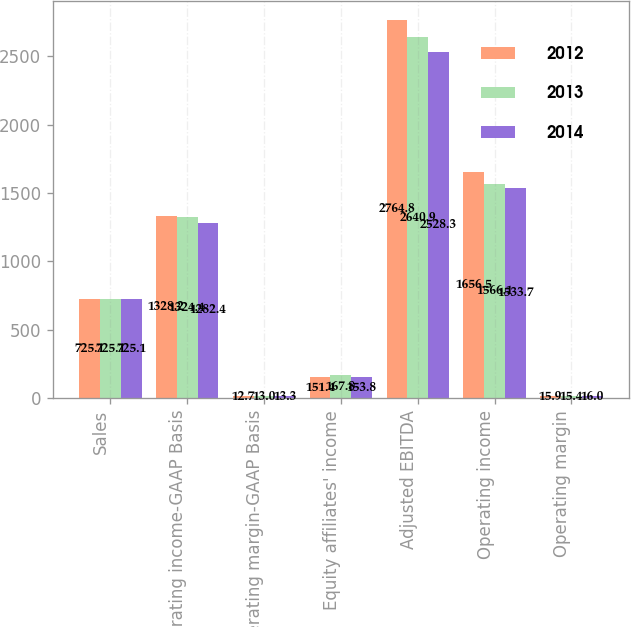<chart> <loc_0><loc_0><loc_500><loc_500><stacked_bar_chart><ecel><fcel>Sales<fcel>Operating income-GAAP Basis<fcel>Operating margin-GAAP Basis<fcel>Equity affiliates' income<fcel>Adjusted EBITDA<fcel>Operating income<fcel>Operating margin<nl><fcel>2012<fcel>725.1<fcel>1328.2<fcel>12.7<fcel>151.4<fcel>2764.8<fcel>1656.5<fcel>15.9<nl><fcel>2013<fcel>725.1<fcel>1324.4<fcel>13<fcel>167.8<fcel>2640.9<fcel>1566.1<fcel>15.4<nl><fcel>2014<fcel>725.1<fcel>1282.4<fcel>13.3<fcel>153.8<fcel>2528.3<fcel>1533.7<fcel>16<nl></chart> 